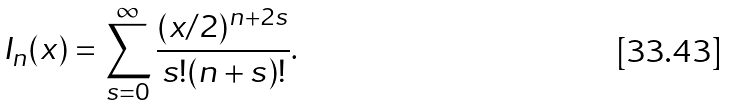Convert formula to latex. <formula><loc_0><loc_0><loc_500><loc_500>I _ { n } ( x ) = \sum _ { s = 0 } ^ { \infty } \frac { ( x / 2 ) ^ { n + 2 s } } { s ! ( n + s ) ! } .</formula> 